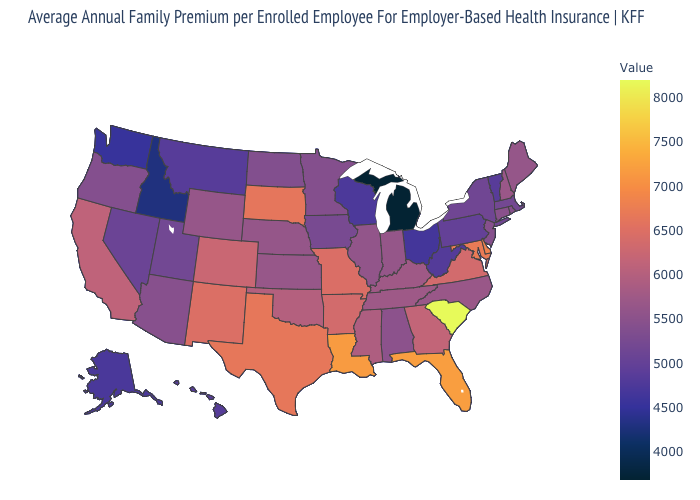Which states have the highest value in the USA?
Quick response, please. South Carolina. Does Illinois have a lower value than Ohio?
Write a very short answer. No. Which states have the lowest value in the USA?
Give a very brief answer. Michigan. Which states hav the highest value in the Northeast?
Keep it brief. New Hampshire. Is the legend a continuous bar?
Write a very short answer. Yes. 